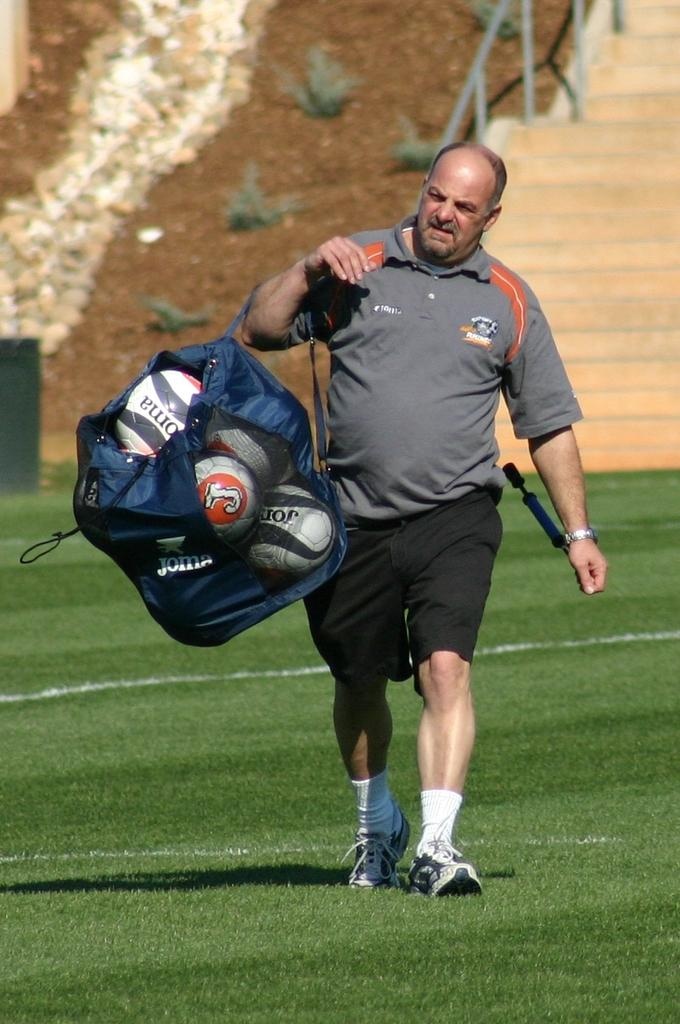What is the main subject of the image? There is a man in the image. What is the man doing in the image? The man is walking in the image. What is the man carrying while walking? The man is carrying a bag in the image. What is inside the bag that the man is carrying? There are balls in the bag. What type of surface is at the bottom of the image? There is grass at the bottom of the image. What can be seen in the background of the image? There are plants, soil, and stairs in the background of the image. What type of water can be seen in the image? There is no water present in the image. What type of protest is happening in the image? There is no protest happening in the image. 